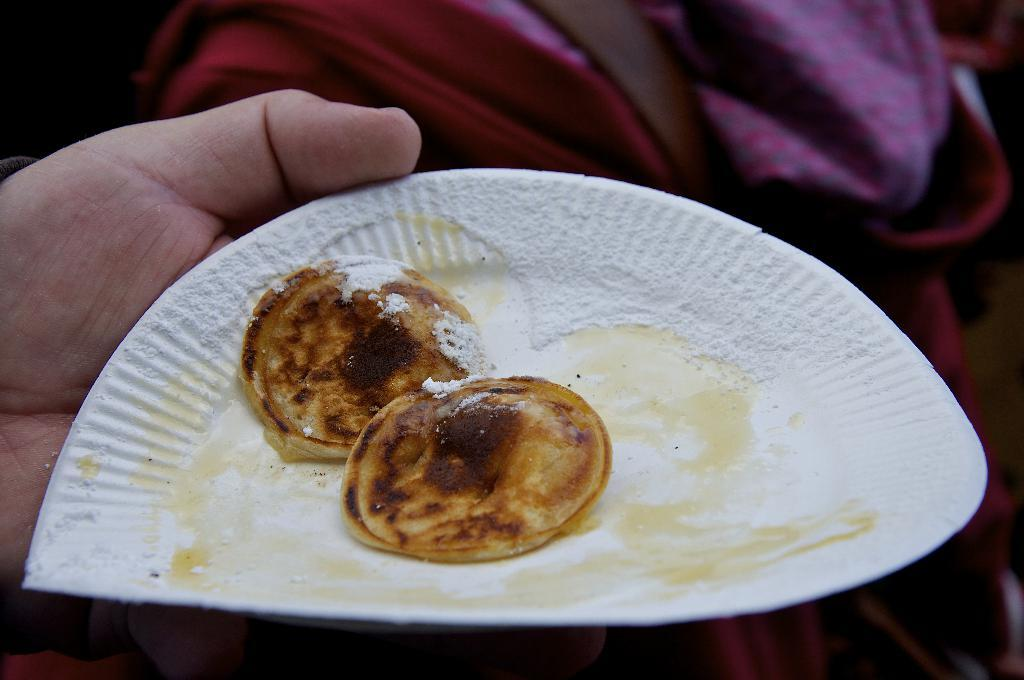What is the person's hand holding in the image? The person's hand is holding a plate in the image. What is on the plate that the hand is holding? The plate contains pickert. Can you describe the background of the image? The background of the image is blurred. Who is the creator of the branch visible in the image? There is no branch visible in the image, so it is not possible to determine who the creator might be. 